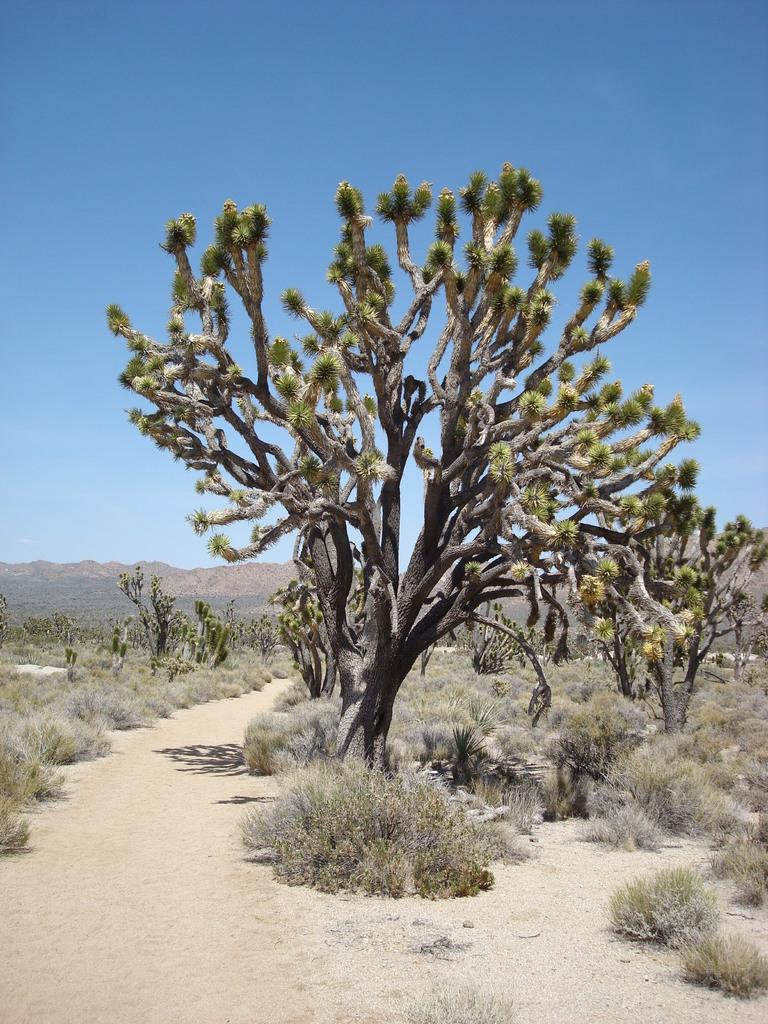What type of vegetation is present in the image? The image contains shrubs, trees, and dry grass. What type of ground surface can be seen in the image? The image contains sand. What is visible in the background of the image? There are hills and trees in the background of the image. What is the weather like in the image? The sky is sunny in the image. Can you tell me how many quinces are hanging from the trees in the image? There are no quinces present in the image; it features trees without any visible fruit. What type of bird is the wren in the image? There is no bird, specifically a wren, present in the image. 